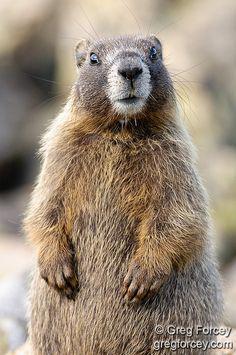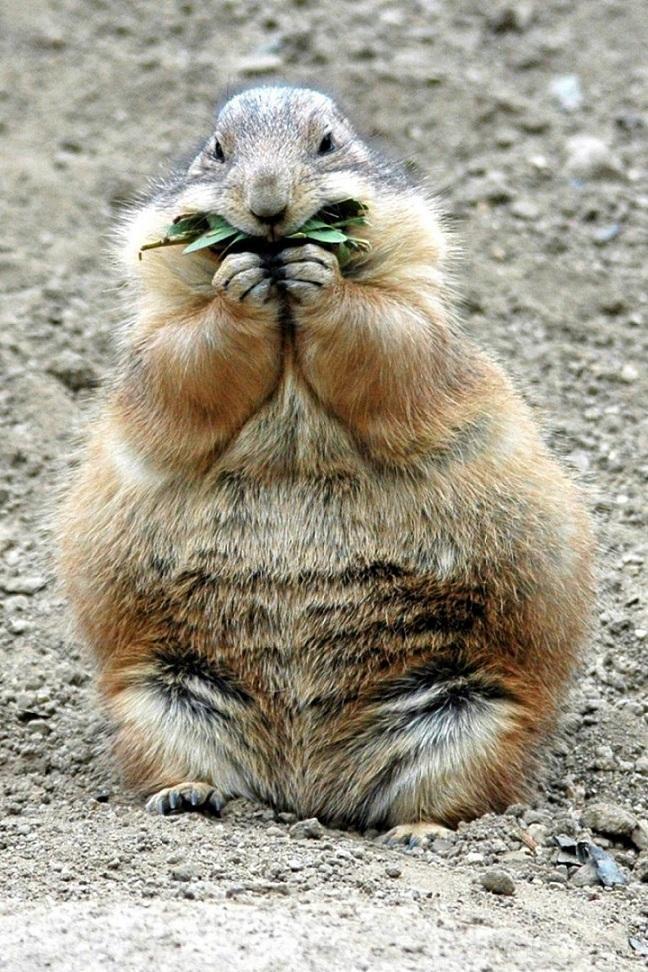The first image is the image on the left, the second image is the image on the right. Analyze the images presented: Is the assertion "In one image the prairie dog is eating food that it is holding in its paws." valid? Answer yes or no. Yes. 